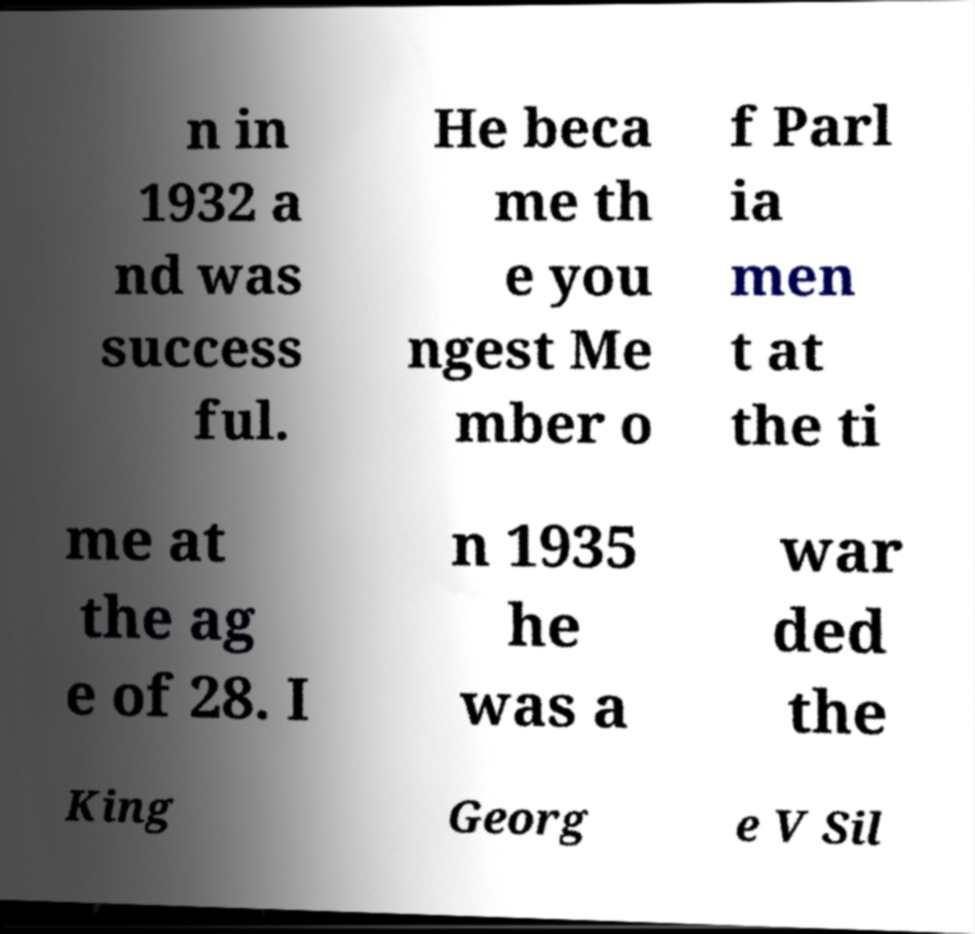Please identify and transcribe the text found in this image. n in 1932 a nd was success ful. He beca me th e you ngest Me mber o f Parl ia men t at the ti me at the ag e of 28. I n 1935 he was a war ded the King Georg e V Sil 